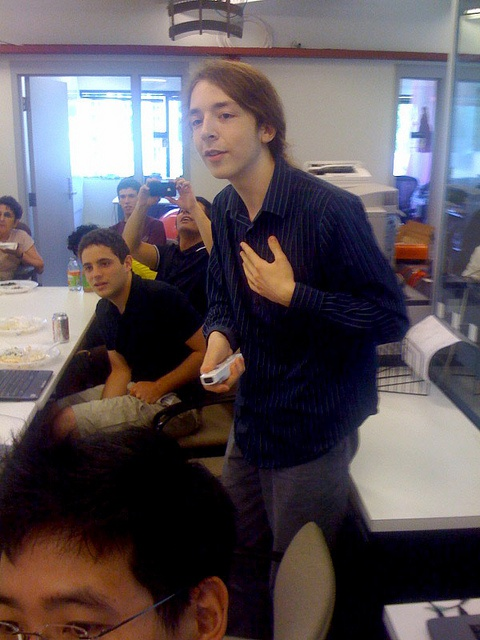Describe the objects in this image and their specific colors. I can see people in darkgray, black, gray, and navy tones, people in darkgray, black, maroon, and brown tones, people in darkgray, black, maroon, and gray tones, dining table in darkgray, lightgray, and gray tones, and dining table in darkgray, lightgray, and tan tones in this image. 